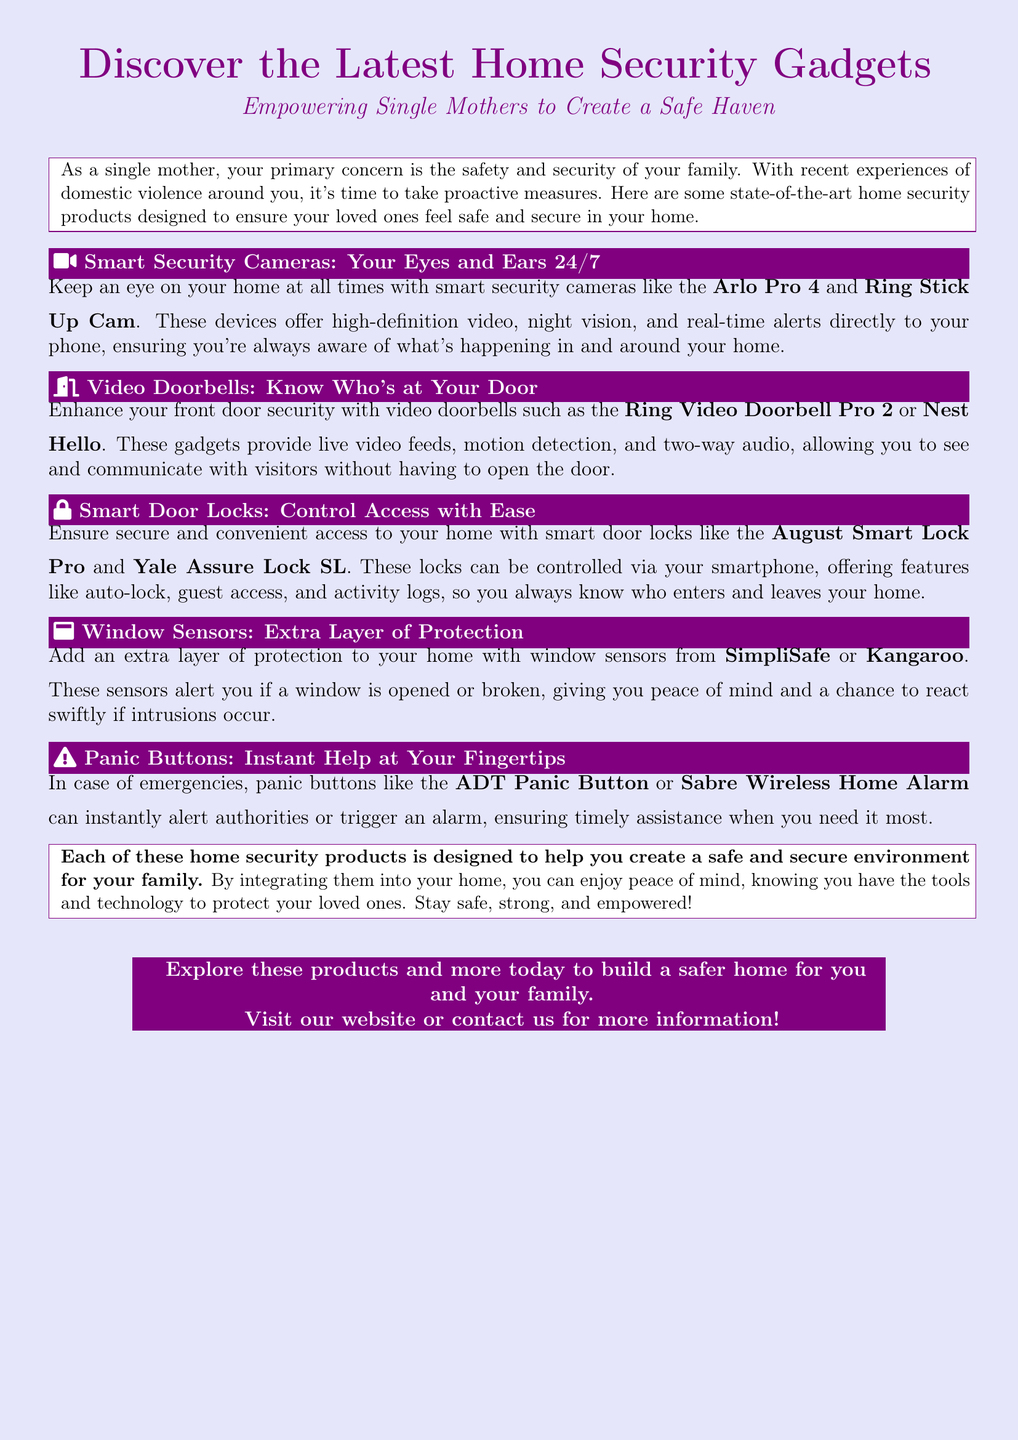What type of product is the Arlo Pro 4? The Arlo Pro 4 is categorized as a smart security camera.
Answer: smart security camera What feature do video doorbells like the Ring Video Doorbell Pro 2 offer? Video doorbells provide live video feeds.
Answer: live video feeds What is a key functionality of smart door locks like the August Smart Lock Pro? A key functionality of smart door locks is smartphone control.
Answer: smartphone control Which product alerts you if a window is opened or broken? Window sensors from SimpliSafe or Kangaroo alert you for such events.
Answer: window sensors What can panic buttons like the ADT Panic Button do in emergencies? Panic buttons can instantly alert authorities.
Answer: alert authorities How many types of home security products are mentioned in the document? There are five types of products mentioned.
Answer: five What color is used for the advertisement's background? The advertisement's background color is lavender.
Answer: lavender What is the primary goal of the home security products listed? The primary goal is to create a safe and secure environment.
Answer: safe and secure environment Who is the target audience of this advertisement? The target audience is single mothers.
Answer: single mothers 